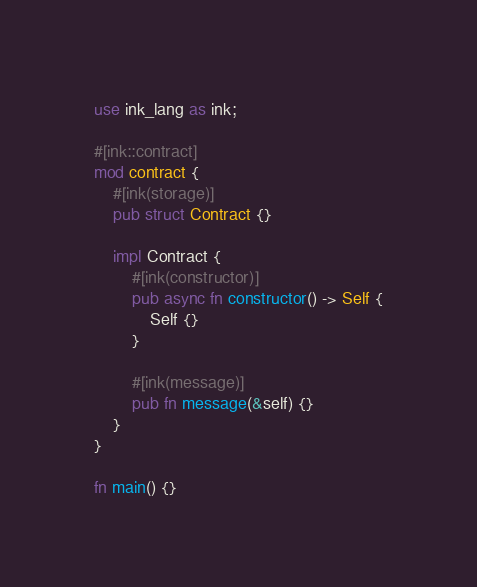<code> <loc_0><loc_0><loc_500><loc_500><_Rust_>use ink_lang as ink;

#[ink::contract]
mod contract {
    #[ink(storage)]
    pub struct Contract {}

    impl Contract {
        #[ink(constructor)]
        pub async fn constructor() -> Self {
            Self {}
        }

        #[ink(message)]
        pub fn message(&self) {}
    }
}

fn main() {}
</code> 